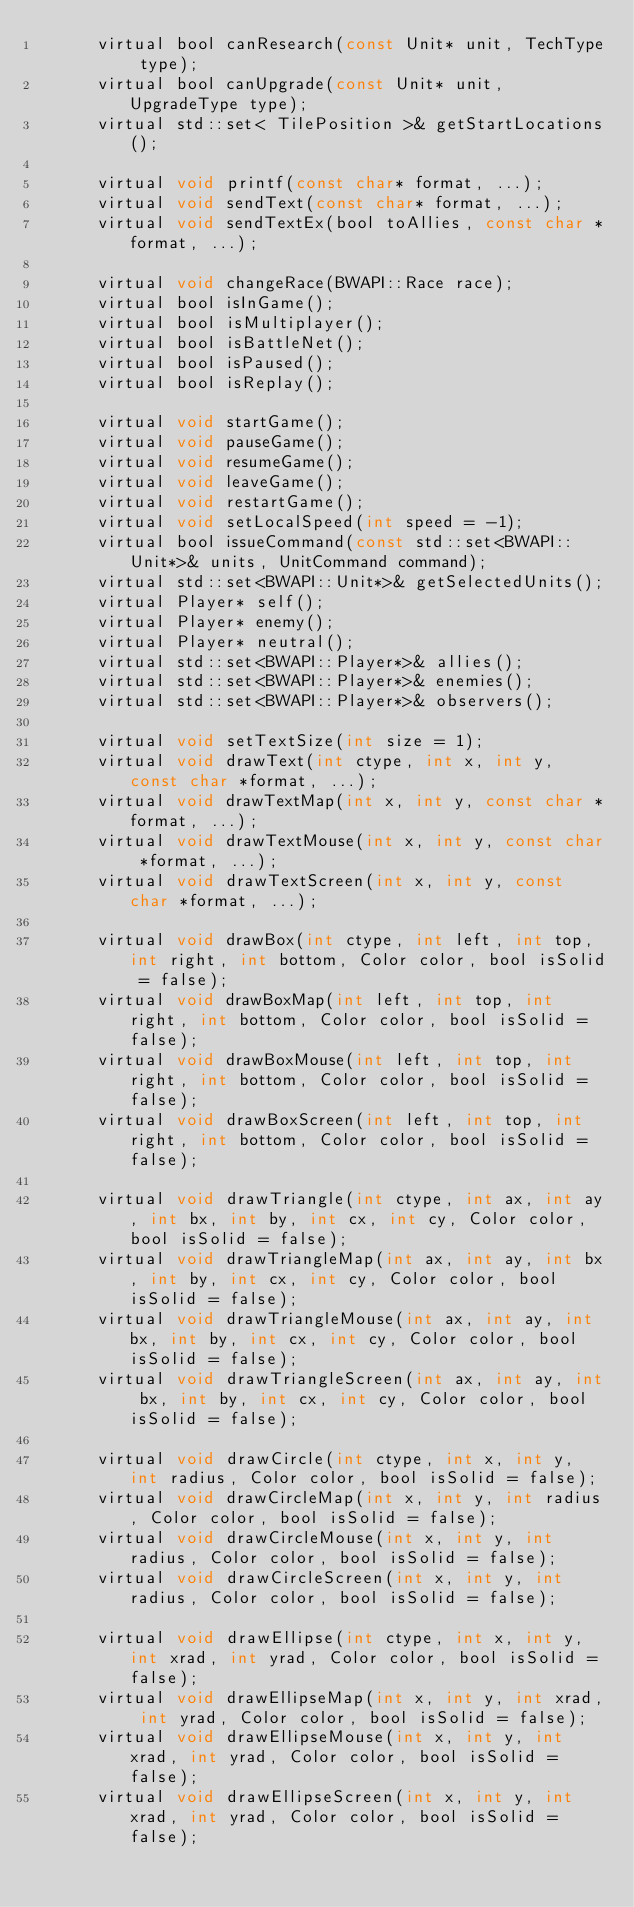Convert code to text. <code><loc_0><loc_0><loc_500><loc_500><_C_>      virtual bool canResearch(const Unit* unit, TechType type);
      virtual bool canUpgrade(const Unit* unit, UpgradeType type);
      virtual std::set< TilePosition >& getStartLocations();

      virtual void printf(const char* format, ...);
      virtual void sendText(const char* format, ...);
      virtual void sendTextEx(bool toAllies, const char *format, ...);

      virtual void changeRace(BWAPI::Race race);
      virtual bool isInGame();
      virtual bool isMultiplayer();
      virtual bool isBattleNet();
      virtual bool isPaused();
      virtual bool isReplay();

      virtual void startGame();
      virtual void pauseGame();
      virtual void resumeGame();
      virtual void leaveGame();
      virtual void restartGame();
      virtual void setLocalSpeed(int speed = -1);
      virtual bool issueCommand(const std::set<BWAPI::Unit*>& units, UnitCommand command);
      virtual std::set<BWAPI::Unit*>& getSelectedUnits();
      virtual Player* self();
      virtual Player* enemy();
      virtual Player* neutral();
      virtual std::set<BWAPI::Player*>& allies();
      virtual std::set<BWAPI::Player*>& enemies();
      virtual std::set<BWAPI::Player*>& observers();

      virtual void setTextSize(int size = 1);
      virtual void drawText(int ctype, int x, int y, const char *format, ...);
      virtual void drawTextMap(int x, int y, const char *format, ...);
      virtual void drawTextMouse(int x, int y, const char *format, ...);
      virtual void drawTextScreen(int x, int y, const char *format, ...);

      virtual void drawBox(int ctype, int left, int top, int right, int bottom, Color color, bool isSolid = false);
      virtual void drawBoxMap(int left, int top, int right, int bottom, Color color, bool isSolid = false);
      virtual void drawBoxMouse(int left, int top, int right, int bottom, Color color, bool isSolid = false);
      virtual void drawBoxScreen(int left, int top, int right, int bottom, Color color, bool isSolid = false);

      virtual void drawTriangle(int ctype, int ax, int ay, int bx, int by, int cx, int cy, Color color, bool isSolid = false);
      virtual void drawTriangleMap(int ax, int ay, int bx, int by, int cx, int cy, Color color, bool isSolid = false);
      virtual void drawTriangleMouse(int ax, int ay, int bx, int by, int cx, int cy, Color color, bool isSolid = false);
      virtual void drawTriangleScreen(int ax, int ay, int bx, int by, int cx, int cy, Color color, bool isSolid = false);

      virtual void drawCircle(int ctype, int x, int y, int radius, Color color, bool isSolid = false);
      virtual void drawCircleMap(int x, int y, int radius, Color color, bool isSolid = false);
      virtual void drawCircleMouse(int x, int y, int radius, Color color, bool isSolid = false);
      virtual void drawCircleScreen(int x, int y, int radius, Color color, bool isSolid = false);

      virtual void drawEllipse(int ctype, int x, int y, int xrad, int yrad, Color color, bool isSolid = false);
      virtual void drawEllipseMap(int x, int y, int xrad, int yrad, Color color, bool isSolid = false);
      virtual void drawEllipseMouse(int x, int y, int xrad, int yrad, Color color, bool isSolid = false);
      virtual void drawEllipseScreen(int x, int y, int xrad, int yrad, Color color, bool isSolid = false);
</code> 